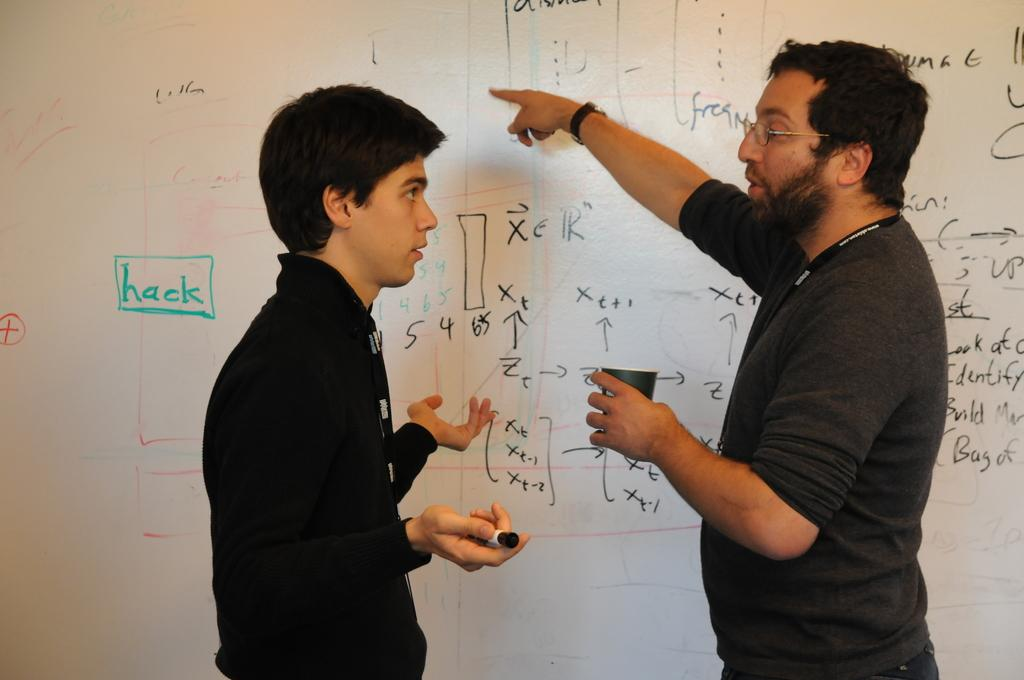<image>
Summarize the visual content of the image. A man points to a whiteboard that says "hack" as he talks to another guy. 